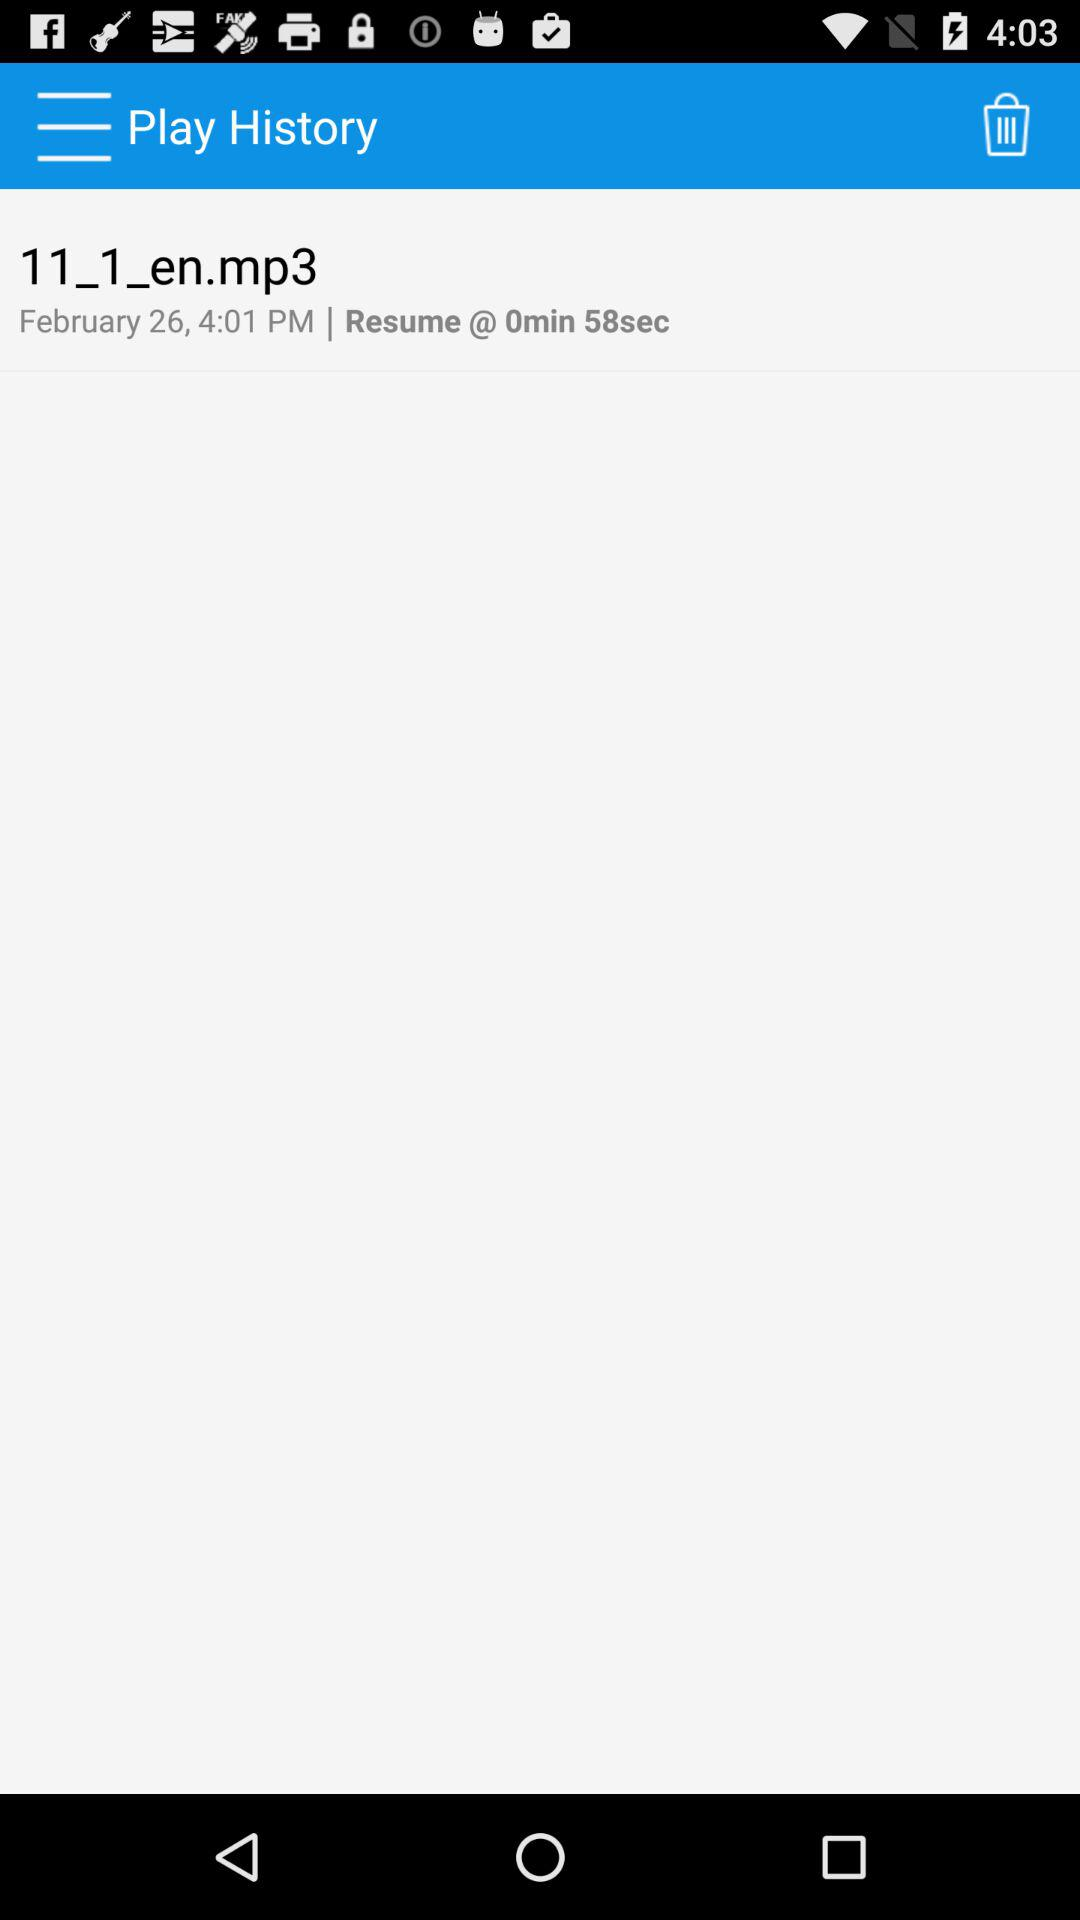What is the given time? The given time is 4:01 PM. 